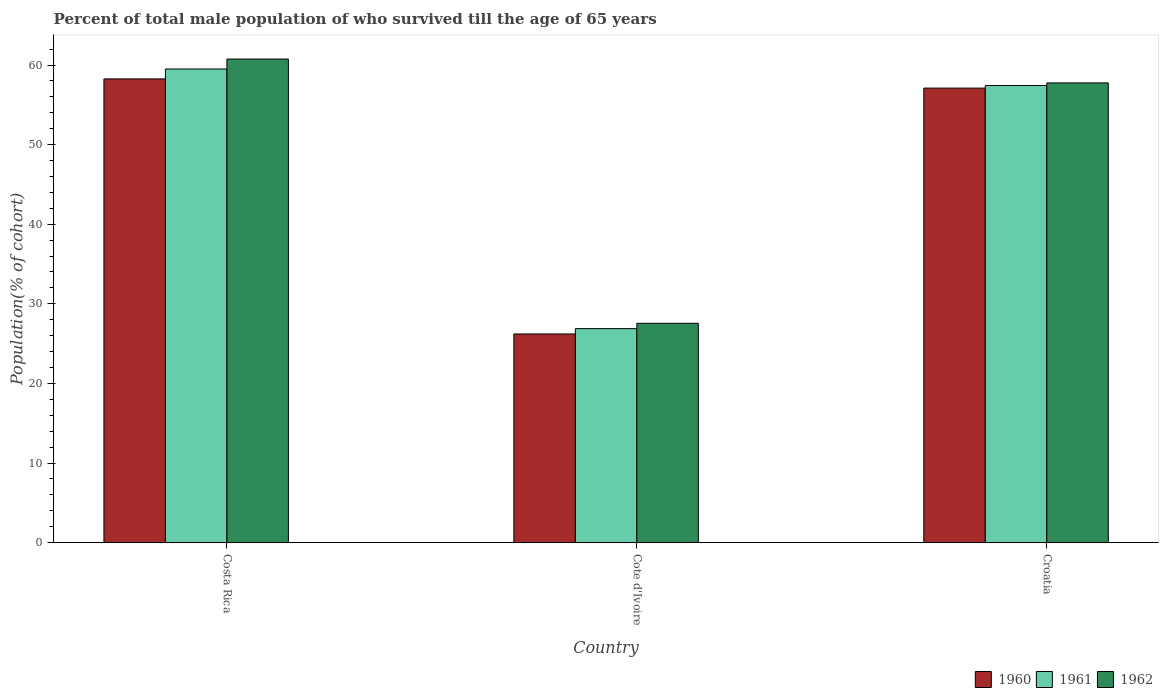How many different coloured bars are there?
Provide a succinct answer. 3. How many bars are there on the 3rd tick from the right?
Make the answer very short. 3. What is the label of the 3rd group of bars from the left?
Your answer should be compact. Croatia. What is the percentage of total male population who survived till the age of 65 years in 1961 in Cote d'Ivoire?
Provide a short and direct response. 26.88. Across all countries, what is the maximum percentage of total male population who survived till the age of 65 years in 1960?
Your answer should be compact. 58.26. Across all countries, what is the minimum percentage of total male population who survived till the age of 65 years in 1960?
Offer a terse response. 26.21. In which country was the percentage of total male population who survived till the age of 65 years in 1960 minimum?
Provide a succinct answer. Cote d'Ivoire. What is the total percentage of total male population who survived till the age of 65 years in 1961 in the graph?
Provide a short and direct response. 143.82. What is the difference between the percentage of total male population who survived till the age of 65 years in 1960 in Cote d'Ivoire and that in Croatia?
Your answer should be compact. -30.89. What is the difference between the percentage of total male population who survived till the age of 65 years in 1961 in Cote d'Ivoire and the percentage of total male population who survived till the age of 65 years in 1960 in Costa Rica?
Your answer should be very brief. -31.38. What is the average percentage of total male population who survived till the age of 65 years in 1962 per country?
Offer a very short reply. 48.69. What is the difference between the percentage of total male population who survived till the age of 65 years of/in 1962 and percentage of total male population who survived till the age of 65 years of/in 1961 in Cote d'Ivoire?
Give a very brief answer. 0.67. What is the ratio of the percentage of total male population who survived till the age of 65 years in 1961 in Cote d'Ivoire to that in Croatia?
Offer a very short reply. 0.47. What is the difference between the highest and the second highest percentage of total male population who survived till the age of 65 years in 1962?
Provide a short and direct response. 30.2. What is the difference between the highest and the lowest percentage of total male population who survived till the age of 65 years in 1960?
Your answer should be compact. 32.05. In how many countries, is the percentage of total male population who survived till the age of 65 years in 1961 greater than the average percentage of total male population who survived till the age of 65 years in 1961 taken over all countries?
Your answer should be very brief. 2. Is it the case that in every country, the sum of the percentage of total male population who survived till the age of 65 years in 1961 and percentage of total male population who survived till the age of 65 years in 1960 is greater than the percentage of total male population who survived till the age of 65 years in 1962?
Your response must be concise. Yes. How many bars are there?
Offer a terse response. 9. Are all the bars in the graph horizontal?
Your answer should be very brief. No. How many countries are there in the graph?
Provide a succinct answer. 3. What is the difference between two consecutive major ticks on the Y-axis?
Make the answer very short. 10. Are the values on the major ticks of Y-axis written in scientific E-notation?
Your answer should be very brief. No. Does the graph contain any zero values?
Give a very brief answer. No. Does the graph contain grids?
Offer a very short reply. No. How many legend labels are there?
Your response must be concise. 3. What is the title of the graph?
Your answer should be compact. Percent of total male population of who survived till the age of 65 years. What is the label or title of the Y-axis?
Offer a terse response. Population(% of cohort). What is the Population(% of cohort) in 1960 in Costa Rica?
Make the answer very short. 58.26. What is the Population(% of cohort) in 1961 in Costa Rica?
Ensure brevity in your answer.  59.51. What is the Population(% of cohort) of 1962 in Costa Rica?
Offer a very short reply. 60.76. What is the Population(% of cohort) of 1960 in Cote d'Ivoire?
Your response must be concise. 26.21. What is the Population(% of cohort) in 1961 in Cote d'Ivoire?
Keep it short and to the point. 26.88. What is the Population(% of cohort) of 1962 in Cote d'Ivoire?
Offer a very short reply. 27.55. What is the Population(% of cohort) of 1960 in Croatia?
Offer a terse response. 57.1. What is the Population(% of cohort) of 1961 in Croatia?
Ensure brevity in your answer.  57.43. What is the Population(% of cohort) in 1962 in Croatia?
Offer a terse response. 57.76. Across all countries, what is the maximum Population(% of cohort) of 1960?
Give a very brief answer. 58.26. Across all countries, what is the maximum Population(% of cohort) of 1961?
Provide a succinct answer. 59.51. Across all countries, what is the maximum Population(% of cohort) in 1962?
Provide a short and direct response. 60.76. Across all countries, what is the minimum Population(% of cohort) in 1960?
Provide a succinct answer. 26.21. Across all countries, what is the minimum Population(% of cohort) of 1961?
Ensure brevity in your answer.  26.88. Across all countries, what is the minimum Population(% of cohort) in 1962?
Your answer should be very brief. 27.55. What is the total Population(% of cohort) of 1960 in the graph?
Your answer should be compact. 141.58. What is the total Population(% of cohort) in 1961 in the graph?
Ensure brevity in your answer.  143.82. What is the total Population(% of cohort) in 1962 in the graph?
Your answer should be very brief. 146.07. What is the difference between the Population(% of cohort) in 1960 in Costa Rica and that in Cote d'Ivoire?
Your answer should be compact. 32.05. What is the difference between the Population(% of cohort) of 1961 in Costa Rica and that in Cote d'Ivoire?
Your answer should be very brief. 32.62. What is the difference between the Population(% of cohort) of 1962 in Costa Rica and that in Cote d'Ivoire?
Give a very brief answer. 33.2. What is the difference between the Population(% of cohort) of 1960 in Costa Rica and that in Croatia?
Your response must be concise. 1.16. What is the difference between the Population(% of cohort) in 1961 in Costa Rica and that in Croatia?
Give a very brief answer. 2.08. What is the difference between the Population(% of cohort) in 1962 in Costa Rica and that in Croatia?
Give a very brief answer. 3. What is the difference between the Population(% of cohort) in 1960 in Cote d'Ivoire and that in Croatia?
Your answer should be compact. -30.89. What is the difference between the Population(% of cohort) of 1961 in Cote d'Ivoire and that in Croatia?
Provide a short and direct response. -30.55. What is the difference between the Population(% of cohort) of 1962 in Cote d'Ivoire and that in Croatia?
Keep it short and to the point. -30.2. What is the difference between the Population(% of cohort) of 1960 in Costa Rica and the Population(% of cohort) of 1961 in Cote d'Ivoire?
Offer a terse response. 31.38. What is the difference between the Population(% of cohort) of 1960 in Costa Rica and the Population(% of cohort) of 1962 in Cote d'Ivoire?
Your response must be concise. 30.71. What is the difference between the Population(% of cohort) in 1961 in Costa Rica and the Population(% of cohort) in 1962 in Cote d'Ivoire?
Keep it short and to the point. 31.95. What is the difference between the Population(% of cohort) of 1960 in Costa Rica and the Population(% of cohort) of 1961 in Croatia?
Your answer should be compact. 0.83. What is the difference between the Population(% of cohort) in 1960 in Costa Rica and the Population(% of cohort) in 1962 in Croatia?
Offer a terse response. 0.5. What is the difference between the Population(% of cohort) in 1961 in Costa Rica and the Population(% of cohort) in 1962 in Croatia?
Offer a very short reply. 1.75. What is the difference between the Population(% of cohort) of 1960 in Cote d'Ivoire and the Population(% of cohort) of 1961 in Croatia?
Your answer should be very brief. -31.22. What is the difference between the Population(% of cohort) of 1960 in Cote d'Ivoire and the Population(% of cohort) of 1962 in Croatia?
Provide a succinct answer. -31.54. What is the difference between the Population(% of cohort) of 1961 in Cote d'Ivoire and the Population(% of cohort) of 1962 in Croatia?
Keep it short and to the point. -30.87. What is the average Population(% of cohort) in 1960 per country?
Ensure brevity in your answer.  47.19. What is the average Population(% of cohort) in 1961 per country?
Your answer should be very brief. 47.94. What is the average Population(% of cohort) in 1962 per country?
Provide a short and direct response. 48.69. What is the difference between the Population(% of cohort) in 1960 and Population(% of cohort) in 1961 in Costa Rica?
Offer a very short reply. -1.25. What is the difference between the Population(% of cohort) of 1960 and Population(% of cohort) of 1962 in Costa Rica?
Your answer should be compact. -2.49. What is the difference between the Population(% of cohort) of 1961 and Population(% of cohort) of 1962 in Costa Rica?
Give a very brief answer. -1.25. What is the difference between the Population(% of cohort) of 1960 and Population(% of cohort) of 1961 in Cote d'Ivoire?
Your answer should be compact. -0.67. What is the difference between the Population(% of cohort) of 1960 and Population(% of cohort) of 1962 in Cote d'Ivoire?
Provide a succinct answer. -1.34. What is the difference between the Population(% of cohort) in 1961 and Population(% of cohort) in 1962 in Cote d'Ivoire?
Keep it short and to the point. -0.67. What is the difference between the Population(% of cohort) in 1960 and Population(% of cohort) in 1961 in Croatia?
Your response must be concise. -0.33. What is the difference between the Population(% of cohort) of 1960 and Population(% of cohort) of 1962 in Croatia?
Ensure brevity in your answer.  -0.65. What is the difference between the Population(% of cohort) of 1961 and Population(% of cohort) of 1962 in Croatia?
Give a very brief answer. -0.33. What is the ratio of the Population(% of cohort) in 1960 in Costa Rica to that in Cote d'Ivoire?
Offer a very short reply. 2.22. What is the ratio of the Population(% of cohort) in 1961 in Costa Rica to that in Cote d'Ivoire?
Make the answer very short. 2.21. What is the ratio of the Population(% of cohort) of 1962 in Costa Rica to that in Cote d'Ivoire?
Offer a terse response. 2.2. What is the ratio of the Population(% of cohort) of 1960 in Costa Rica to that in Croatia?
Give a very brief answer. 1.02. What is the ratio of the Population(% of cohort) in 1961 in Costa Rica to that in Croatia?
Ensure brevity in your answer.  1.04. What is the ratio of the Population(% of cohort) in 1962 in Costa Rica to that in Croatia?
Offer a very short reply. 1.05. What is the ratio of the Population(% of cohort) of 1960 in Cote d'Ivoire to that in Croatia?
Provide a succinct answer. 0.46. What is the ratio of the Population(% of cohort) of 1961 in Cote d'Ivoire to that in Croatia?
Ensure brevity in your answer.  0.47. What is the ratio of the Population(% of cohort) of 1962 in Cote d'Ivoire to that in Croatia?
Offer a terse response. 0.48. What is the difference between the highest and the second highest Population(% of cohort) of 1960?
Your answer should be compact. 1.16. What is the difference between the highest and the second highest Population(% of cohort) in 1961?
Your response must be concise. 2.08. What is the difference between the highest and the second highest Population(% of cohort) in 1962?
Give a very brief answer. 3. What is the difference between the highest and the lowest Population(% of cohort) of 1960?
Make the answer very short. 32.05. What is the difference between the highest and the lowest Population(% of cohort) of 1961?
Give a very brief answer. 32.62. What is the difference between the highest and the lowest Population(% of cohort) of 1962?
Provide a succinct answer. 33.2. 